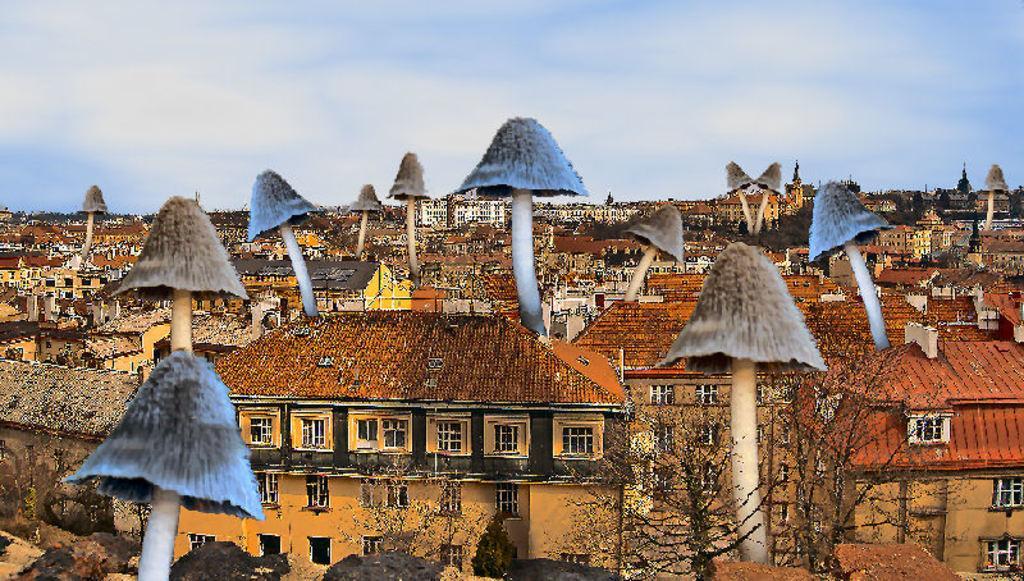Please provide a concise description of this image. It is an edited picture. In the center of the image we can see the sky, clouds, buildings, mushrooms and a few other objects. 